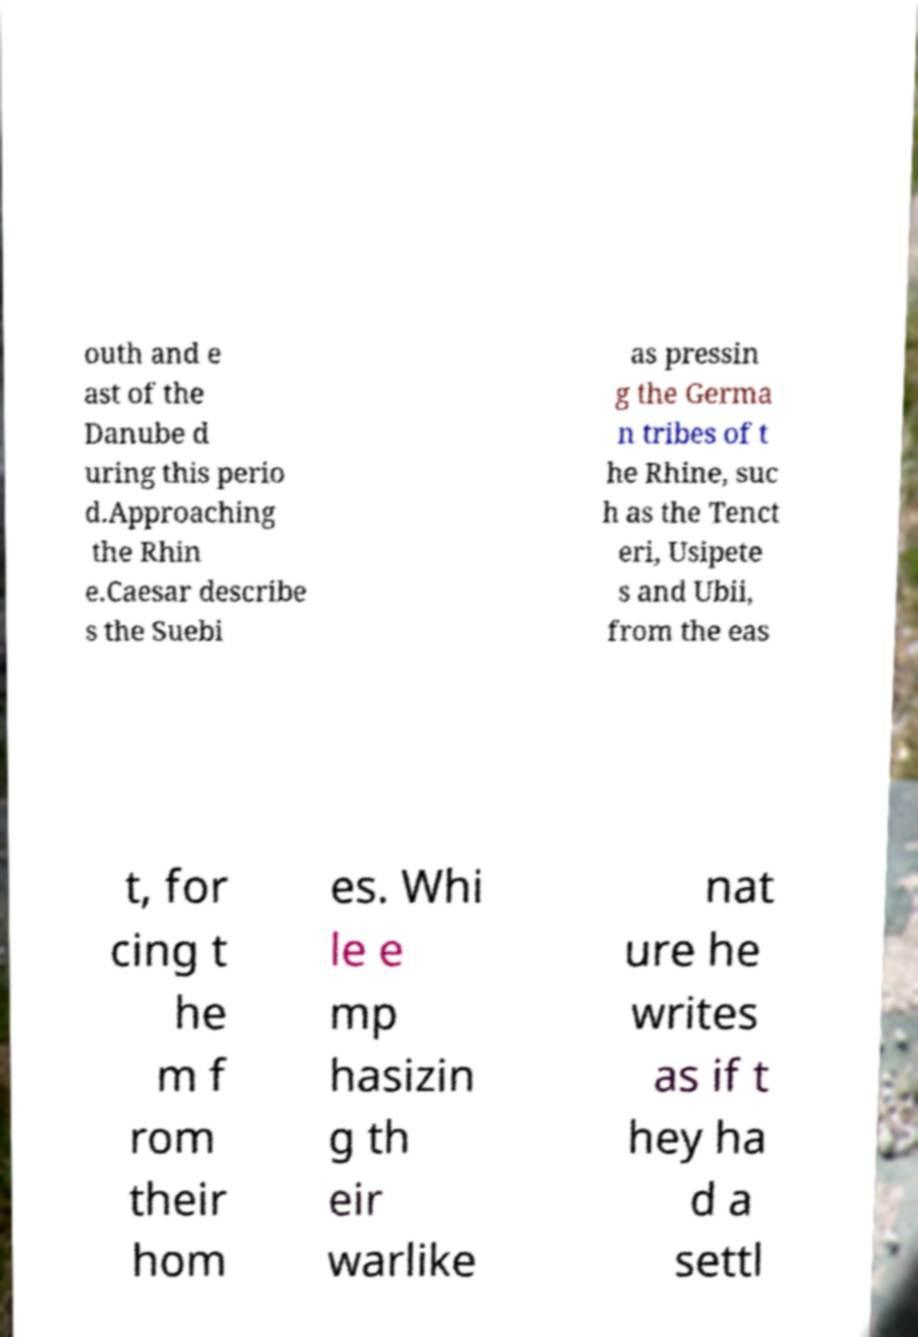I need the written content from this picture converted into text. Can you do that? outh and e ast of the Danube d uring this perio d.Approaching the Rhin e.Caesar describe s the Suebi as pressin g the Germa n tribes of t he Rhine, suc h as the Tenct eri, Usipete s and Ubii, from the eas t, for cing t he m f rom their hom es. Whi le e mp hasizin g th eir warlike nat ure he writes as if t hey ha d a settl 